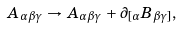<formula> <loc_0><loc_0><loc_500><loc_500>A _ { \alpha \beta \gamma } \, \rightarrow \, A _ { \alpha \beta \gamma } \, + \, \partial _ { [ \alpha } B _ { \beta \gamma ] } ,</formula> 